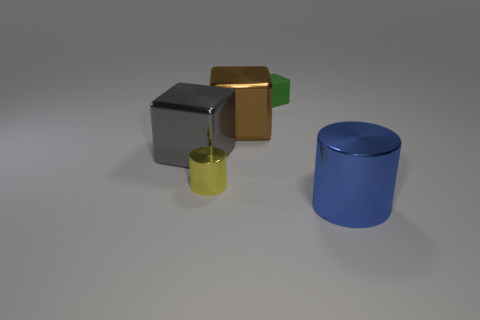How do the objects interact with light, and what does that suggest about their materials? Each object reflects light differently. The grey cube reflects light softly, indicating a matte surface, while the golden and yellow ones have more specular highlights, suggesting metallic properties. The green cube has a subtle shine, indicating a possible plastic material, and the blue cylinder has a smooth, reflective surface, which might imply a painted or enameled finish. 